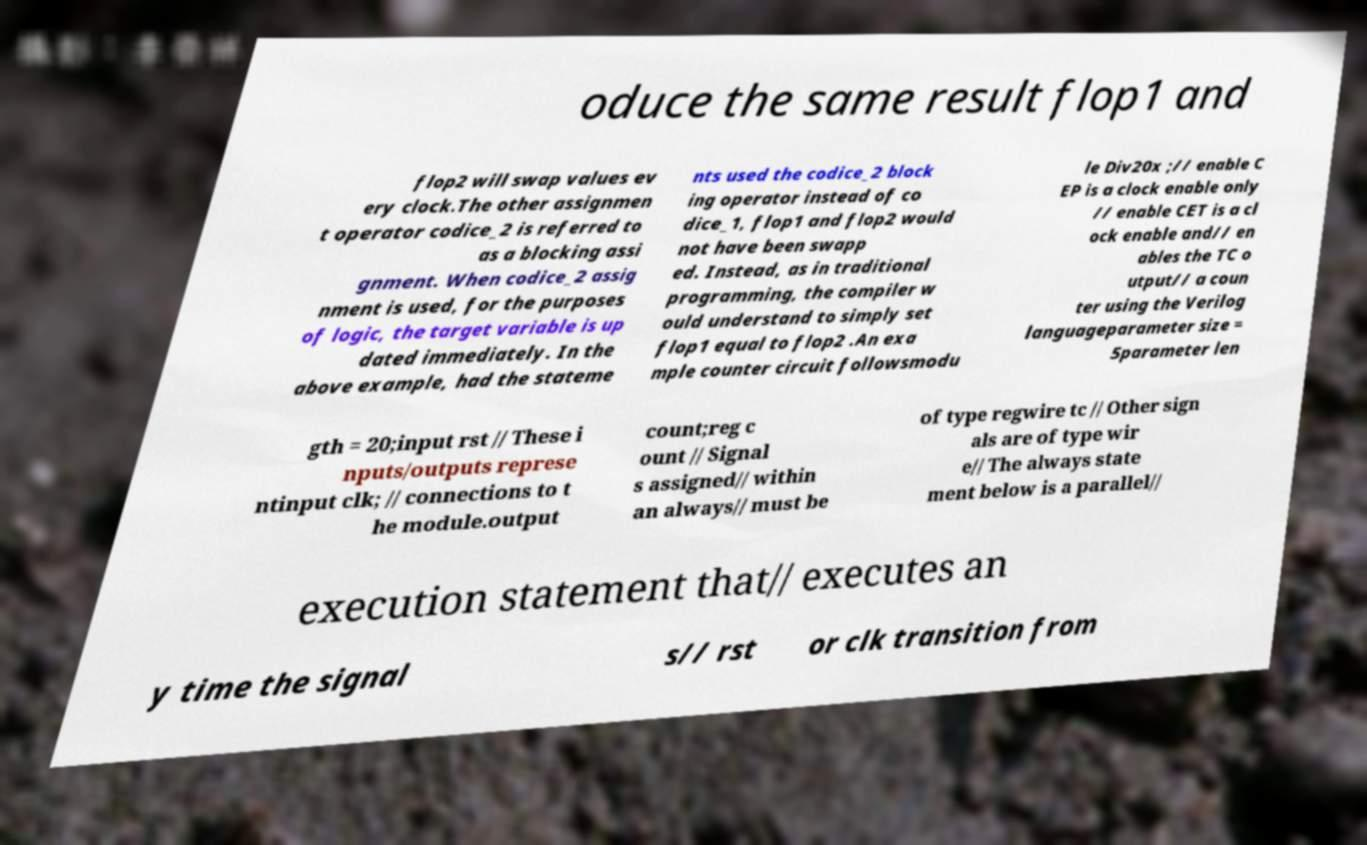Can you accurately transcribe the text from the provided image for me? oduce the same result flop1 and flop2 will swap values ev ery clock.The other assignmen t operator codice_2 is referred to as a blocking assi gnment. When codice_2 assig nment is used, for the purposes of logic, the target variable is up dated immediately. In the above example, had the stateme nts used the codice_2 block ing operator instead of co dice_1, flop1 and flop2 would not have been swapp ed. Instead, as in traditional programming, the compiler w ould understand to simply set flop1 equal to flop2 .An exa mple counter circuit followsmodu le Div20x ;// enable C EP is a clock enable only // enable CET is a cl ock enable and// en ables the TC o utput// a coun ter using the Verilog languageparameter size = 5parameter len gth = 20;input rst // These i nputs/outputs represe ntinput clk; // connections to t he module.output count;reg c ount // Signal s assigned// within an always// must be of type regwire tc // Other sign als are of type wir e// The always state ment below is a parallel// execution statement that// executes an y time the signal s// rst or clk transition from 